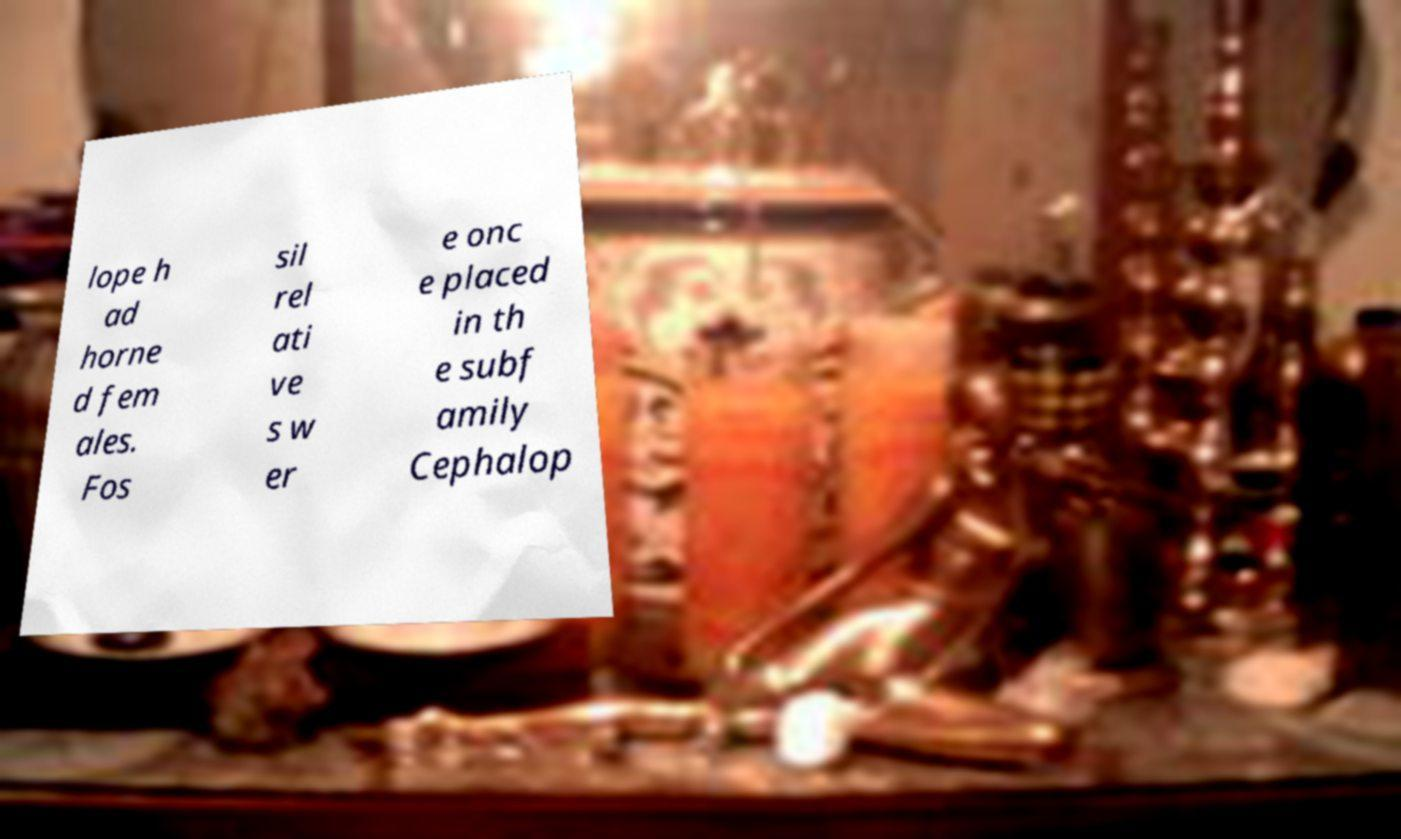Could you assist in decoding the text presented in this image and type it out clearly? lope h ad horne d fem ales. Fos sil rel ati ve s w er e onc e placed in th e subf amily Cephalop 